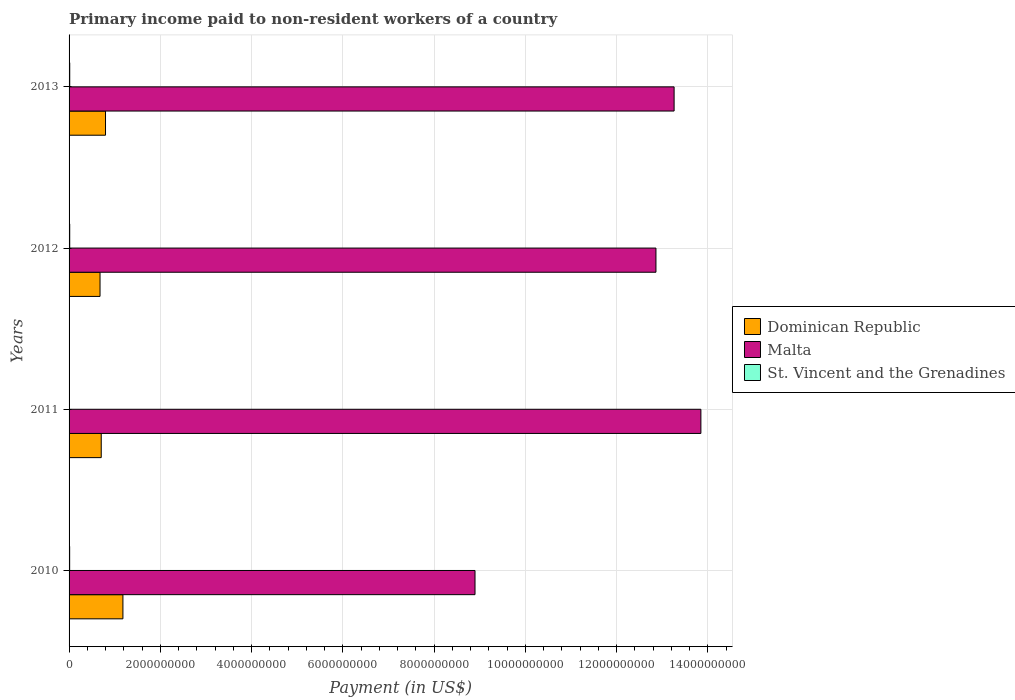How many different coloured bars are there?
Your response must be concise. 3. How many groups of bars are there?
Give a very brief answer. 4. Are the number of bars per tick equal to the number of legend labels?
Offer a very short reply. Yes. In how many cases, is the number of bars for a given year not equal to the number of legend labels?
Offer a very short reply. 0. What is the amount paid to workers in Malta in 2011?
Ensure brevity in your answer.  1.38e+1. Across all years, what is the maximum amount paid to workers in Dominican Republic?
Make the answer very short. 1.18e+09. Across all years, what is the minimum amount paid to workers in St. Vincent and the Grenadines?
Your response must be concise. 9.53e+06. In which year was the amount paid to workers in St. Vincent and the Grenadines maximum?
Provide a succinct answer. 2013. In which year was the amount paid to workers in Dominican Republic minimum?
Your response must be concise. 2012. What is the total amount paid to workers in St. Vincent and the Grenadines in the graph?
Make the answer very short. 5.09e+07. What is the difference between the amount paid to workers in Dominican Republic in 2012 and that in 2013?
Your answer should be very brief. -1.20e+08. What is the difference between the amount paid to workers in Malta in 2010 and the amount paid to workers in Dominican Republic in 2013?
Keep it short and to the point. 8.10e+09. What is the average amount paid to workers in Dominican Republic per year?
Offer a very short reply. 8.40e+08. In the year 2012, what is the difference between the amount paid to workers in Malta and amount paid to workers in Dominican Republic?
Provide a short and direct response. 1.22e+1. What is the ratio of the amount paid to workers in Malta in 2011 to that in 2012?
Your answer should be compact. 1.08. Is the difference between the amount paid to workers in Malta in 2011 and 2013 greater than the difference between the amount paid to workers in Dominican Republic in 2011 and 2013?
Your answer should be very brief. Yes. What is the difference between the highest and the second highest amount paid to workers in St. Vincent and the Grenadines?
Ensure brevity in your answer.  4.39e+05. What is the difference between the highest and the lowest amount paid to workers in Dominican Republic?
Ensure brevity in your answer.  5.01e+08. What does the 1st bar from the top in 2012 represents?
Keep it short and to the point. St. Vincent and the Grenadines. What does the 2nd bar from the bottom in 2013 represents?
Give a very brief answer. Malta. Are all the bars in the graph horizontal?
Offer a very short reply. Yes. How many years are there in the graph?
Make the answer very short. 4. What is the difference between two consecutive major ticks on the X-axis?
Make the answer very short. 2.00e+09. Does the graph contain any zero values?
Offer a very short reply. No. Does the graph contain grids?
Your answer should be compact. Yes. Where does the legend appear in the graph?
Your answer should be compact. Center right. How many legend labels are there?
Your answer should be compact. 3. What is the title of the graph?
Your answer should be compact. Primary income paid to non-resident workers of a country. What is the label or title of the X-axis?
Offer a very short reply. Payment (in US$). What is the Payment (in US$) in Dominican Republic in 2010?
Your answer should be very brief. 1.18e+09. What is the Payment (in US$) in Malta in 2010?
Give a very brief answer. 8.90e+09. What is the Payment (in US$) of St. Vincent and the Grenadines in 2010?
Your answer should be compact. 1.27e+07. What is the Payment (in US$) in Dominican Republic in 2011?
Provide a succinct answer. 7.05e+08. What is the Payment (in US$) of Malta in 2011?
Provide a short and direct response. 1.38e+1. What is the Payment (in US$) of St. Vincent and the Grenadines in 2011?
Your answer should be very brief. 9.53e+06. What is the Payment (in US$) in Dominican Republic in 2012?
Give a very brief answer. 6.78e+08. What is the Payment (in US$) of Malta in 2012?
Provide a short and direct response. 1.29e+1. What is the Payment (in US$) of St. Vincent and the Grenadines in 2012?
Offer a terse response. 1.41e+07. What is the Payment (in US$) in Dominican Republic in 2013?
Your response must be concise. 7.99e+08. What is the Payment (in US$) of Malta in 2013?
Provide a succinct answer. 1.33e+1. What is the Payment (in US$) of St. Vincent and the Grenadines in 2013?
Make the answer very short. 1.46e+07. Across all years, what is the maximum Payment (in US$) of Dominican Republic?
Give a very brief answer. 1.18e+09. Across all years, what is the maximum Payment (in US$) in Malta?
Provide a short and direct response. 1.38e+1. Across all years, what is the maximum Payment (in US$) in St. Vincent and the Grenadines?
Provide a succinct answer. 1.46e+07. Across all years, what is the minimum Payment (in US$) in Dominican Republic?
Offer a terse response. 6.78e+08. Across all years, what is the minimum Payment (in US$) in Malta?
Your answer should be very brief. 8.90e+09. Across all years, what is the minimum Payment (in US$) of St. Vincent and the Grenadines?
Give a very brief answer. 9.53e+06. What is the total Payment (in US$) of Dominican Republic in the graph?
Make the answer very short. 3.36e+09. What is the total Payment (in US$) of Malta in the graph?
Offer a terse response. 4.89e+1. What is the total Payment (in US$) of St. Vincent and the Grenadines in the graph?
Ensure brevity in your answer.  5.09e+07. What is the difference between the Payment (in US$) of Dominican Republic in 2010 and that in 2011?
Provide a short and direct response. 4.75e+08. What is the difference between the Payment (in US$) in Malta in 2010 and that in 2011?
Give a very brief answer. -4.95e+09. What is the difference between the Payment (in US$) in St. Vincent and the Grenadines in 2010 and that in 2011?
Offer a terse response. 3.14e+06. What is the difference between the Payment (in US$) in Dominican Republic in 2010 and that in 2012?
Make the answer very short. 5.01e+08. What is the difference between the Payment (in US$) of Malta in 2010 and that in 2012?
Offer a very short reply. -3.97e+09. What is the difference between the Payment (in US$) of St. Vincent and the Grenadines in 2010 and that in 2012?
Offer a very short reply. -1.47e+06. What is the difference between the Payment (in US$) of Dominican Republic in 2010 and that in 2013?
Ensure brevity in your answer.  3.81e+08. What is the difference between the Payment (in US$) in Malta in 2010 and that in 2013?
Offer a terse response. -4.36e+09. What is the difference between the Payment (in US$) in St. Vincent and the Grenadines in 2010 and that in 2013?
Your answer should be compact. -1.91e+06. What is the difference between the Payment (in US$) in Dominican Republic in 2011 and that in 2012?
Your answer should be compact. 2.62e+07. What is the difference between the Payment (in US$) of Malta in 2011 and that in 2012?
Make the answer very short. 9.84e+08. What is the difference between the Payment (in US$) of St. Vincent and the Grenadines in 2011 and that in 2012?
Offer a very short reply. -4.61e+06. What is the difference between the Payment (in US$) of Dominican Republic in 2011 and that in 2013?
Make the answer very short. -9.39e+07. What is the difference between the Payment (in US$) of Malta in 2011 and that in 2013?
Offer a very short reply. 5.87e+08. What is the difference between the Payment (in US$) in St. Vincent and the Grenadines in 2011 and that in 2013?
Provide a succinct answer. -5.05e+06. What is the difference between the Payment (in US$) of Dominican Republic in 2012 and that in 2013?
Your response must be concise. -1.20e+08. What is the difference between the Payment (in US$) in Malta in 2012 and that in 2013?
Ensure brevity in your answer.  -3.98e+08. What is the difference between the Payment (in US$) of St. Vincent and the Grenadines in 2012 and that in 2013?
Keep it short and to the point. -4.39e+05. What is the difference between the Payment (in US$) of Dominican Republic in 2010 and the Payment (in US$) of Malta in 2011?
Provide a short and direct response. -1.27e+1. What is the difference between the Payment (in US$) of Dominican Republic in 2010 and the Payment (in US$) of St. Vincent and the Grenadines in 2011?
Give a very brief answer. 1.17e+09. What is the difference between the Payment (in US$) of Malta in 2010 and the Payment (in US$) of St. Vincent and the Grenadines in 2011?
Provide a short and direct response. 8.89e+09. What is the difference between the Payment (in US$) in Dominican Republic in 2010 and the Payment (in US$) in Malta in 2012?
Give a very brief answer. -1.17e+1. What is the difference between the Payment (in US$) in Dominican Republic in 2010 and the Payment (in US$) in St. Vincent and the Grenadines in 2012?
Provide a succinct answer. 1.17e+09. What is the difference between the Payment (in US$) of Malta in 2010 and the Payment (in US$) of St. Vincent and the Grenadines in 2012?
Provide a succinct answer. 8.88e+09. What is the difference between the Payment (in US$) in Dominican Republic in 2010 and the Payment (in US$) in Malta in 2013?
Offer a very short reply. -1.21e+1. What is the difference between the Payment (in US$) of Dominican Republic in 2010 and the Payment (in US$) of St. Vincent and the Grenadines in 2013?
Provide a short and direct response. 1.17e+09. What is the difference between the Payment (in US$) in Malta in 2010 and the Payment (in US$) in St. Vincent and the Grenadines in 2013?
Your response must be concise. 8.88e+09. What is the difference between the Payment (in US$) of Dominican Republic in 2011 and the Payment (in US$) of Malta in 2012?
Ensure brevity in your answer.  -1.22e+1. What is the difference between the Payment (in US$) of Dominican Republic in 2011 and the Payment (in US$) of St. Vincent and the Grenadines in 2012?
Make the answer very short. 6.91e+08. What is the difference between the Payment (in US$) of Malta in 2011 and the Payment (in US$) of St. Vincent and the Grenadines in 2012?
Your response must be concise. 1.38e+1. What is the difference between the Payment (in US$) in Dominican Republic in 2011 and the Payment (in US$) in Malta in 2013?
Provide a succinct answer. -1.26e+1. What is the difference between the Payment (in US$) in Dominican Republic in 2011 and the Payment (in US$) in St. Vincent and the Grenadines in 2013?
Ensure brevity in your answer.  6.90e+08. What is the difference between the Payment (in US$) in Malta in 2011 and the Payment (in US$) in St. Vincent and the Grenadines in 2013?
Your response must be concise. 1.38e+1. What is the difference between the Payment (in US$) in Dominican Republic in 2012 and the Payment (in US$) in Malta in 2013?
Ensure brevity in your answer.  -1.26e+1. What is the difference between the Payment (in US$) in Dominican Republic in 2012 and the Payment (in US$) in St. Vincent and the Grenadines in 2013?
Your answer should be very brief. 6.64e+08. What is the difference between the Payment (in US$) of Malta in 2012 and the Payment (in US$) of St. Vincent and the Grenadines in 2013?
Offer a very short reply. 1.28e+1. What is the average Payment (in US$) in Dominican Republic per year?
Your response must be concise. 8.40e+08. What is the average Payment (in US$) of Malta per year?
Keep it short and to the point. 1.22e+1. What is the average Payment (in US$) of St. Vincent and the Grenadines per year?
Make the answer very short. 1.27e+07. In the year 2010, what is the difference between the Payment (in US$) of Dominican Republic and Payment (in US$) of Malta?
Make the answer very short. -7.72e+09. In the year 2010, what is the difference between the Payment (in US$) of Dominican Republic and Payment (in US$) of St. Vincent and the Grenadines?
Give a very brief answer. 1.17e+09. In the year 2010, what is the difference between the Payment (in US$) in Malta and Payment (in US$) in St. Vincent and the Grenadines?
Provide a short and direct response. 8.88e+09. In the year 2011, what is the difference between the Payment (in US$) in Dominican Republic and Payment (in US$) in Malta?
Your answer should be compact. -1.31e+1. In the year 2011, what is the difference between the Payment (in US$) of Dominican Republic and Payment (in US$) of St. Vincent and the Grenadines?
Your answer should be compact. 6.95e+08. In the year 2011, what is the difference between the Payment (in US$) in Malta and Payment (in US$) in St. Vincent and the Grenadines?
Give a very brief answer. 1.38e+1. In the year 2012, what is the difference between the Payment (in US$) in Dominican Republic and Payment (in US$) in Malta?
Ensure brevity in your answer.  -1.22e+1. In the year 2012, what is the difference between the Payment (in US$) in Dominican Republic and Payment (in US$) in St. Vincent and the Grenadines?
Your answer should be compact. 6.64e+08. In the year 2012, what is the difference between the Payment (in US$) in Malta and Payment (in US$) in St. Vincent and the Grenadines?
Offer a terse response. 1.28e+1. In the year 2013, what is the difference between the Payment (in US$) in Dominican Republic and Payment (in US$) in Malta?
Offer a terse response. -1.25e+1. In the year 2013, what is the difference between the Payment (in US$) in Dominican Republic and Payment (in US$) in St. Vincent and the Grenadines?
Provide a short and direct response. 7.84e+08. In the year 2013, what is the difference between the Payment (in US$) in Malta and Payment (in US$) in St. Vincent and the Grenadines?
Offer a very short reply. 1.32e+1. What is the ratio of the Payment (in US$) of Dominican Republic in 2010 to that in 2011?
Keep it short and to the point. 1.67. What is the ratio of the Payment (in US$) in Malta in 2010 to that in 2011?
Offer a very short reply. 0.64. What is the ratio of the Payment (in US$) of St. Vincent and the Grenadines in 2010 to that in 2011?
Offer a terse response. 1.33. What is the ratio of the Payment (in US$) in Dominican Republic in 2010 to that in 2012?
Provide a succinct answer. 1.74. What is the ratio of the Payment (in US$) of Malta in 2010 to that in 2012?
Make the answer very short. 0.69. What is the ratio of the Payment (in US$) in St. Vincent and the Grenadines in 2010 to that in 2012?
Offer a very short reply. 0.9. What is the ratio of the Payment (in US$) in Dominican Republic in 2010 to that in 2013?
Provide a short and direct response. 1.48. What is the ratio of the Payment (in US$) of Malta in 2010 to that in 2013?
Ensure brevity in your answer.  0.67. What is the ratio of the Payment (in US$) of St. Vincent and the Grenadines in 2010 to that in 2013?
Make the answer very short. 0.87. What is the ratio of the Payment (in US$) in Dominican Republic in 2011 to that in 2012?
Ensure brevity in your answer.  1.04. What is the ratio of the Payment (in US$) of Malta in 2011 to that in 2012?
Give a very brief answer. 1.08. What is the ratio of the Payment (in US$) of St. Vincent and the Grenadines in 2011 to that in 2012?
Your response must be concise. 0.67. What is the ratio of the Payment (in US$) in Dominican Republic in 2011 to that in 2013?
Your response must be concise. 0.88. What is the ratio of the Payment (in US$) in Malta in 2011 to that in 2013?
Make the answer very short. 1.04. What is the ratio of the Payment (in US$) in St. Vincent and the Grenadines in 2011 to that in 2013?
Provide a succinct answer. 0.65. What is the ratio of the Payment (in US$) of Dominican Republic in 2012 to that in 2013?
Your answer should be compact. 0.85. What is the ratio of the Payment (in US$) in St. Vincent and the Grenadines in 2012 to that in 2013?
Keep it short and to the point. 0.97. What is the difference between the highest and the second highest Payment (in US$) of Dominican Republic?
Your answer should be compact. 3.81e+08. What is the difference between the highest and the second highest Payment (in US$) of Malta?
Provide a succinct answer. 5.87e+08. What is the difference between the highest and the second highest Payment (in US$) in St. Vincent and the Grenadines?
Provide a short and direct response. 4.39e+05. What is the difference between the highest and the lowest Payment (in US$) in Dominican Republic?
Make the answer very short. 5.01e+08. What is the difference between the highest and the lowest Payment (in US$) of Malta?
Provide a succinct answer. 4.95e+09. What is the difference between the highest and the lowest Payment (in US$) in St. Vincent and the Grenadines?
Make the answer very short. 5.05e+06. 